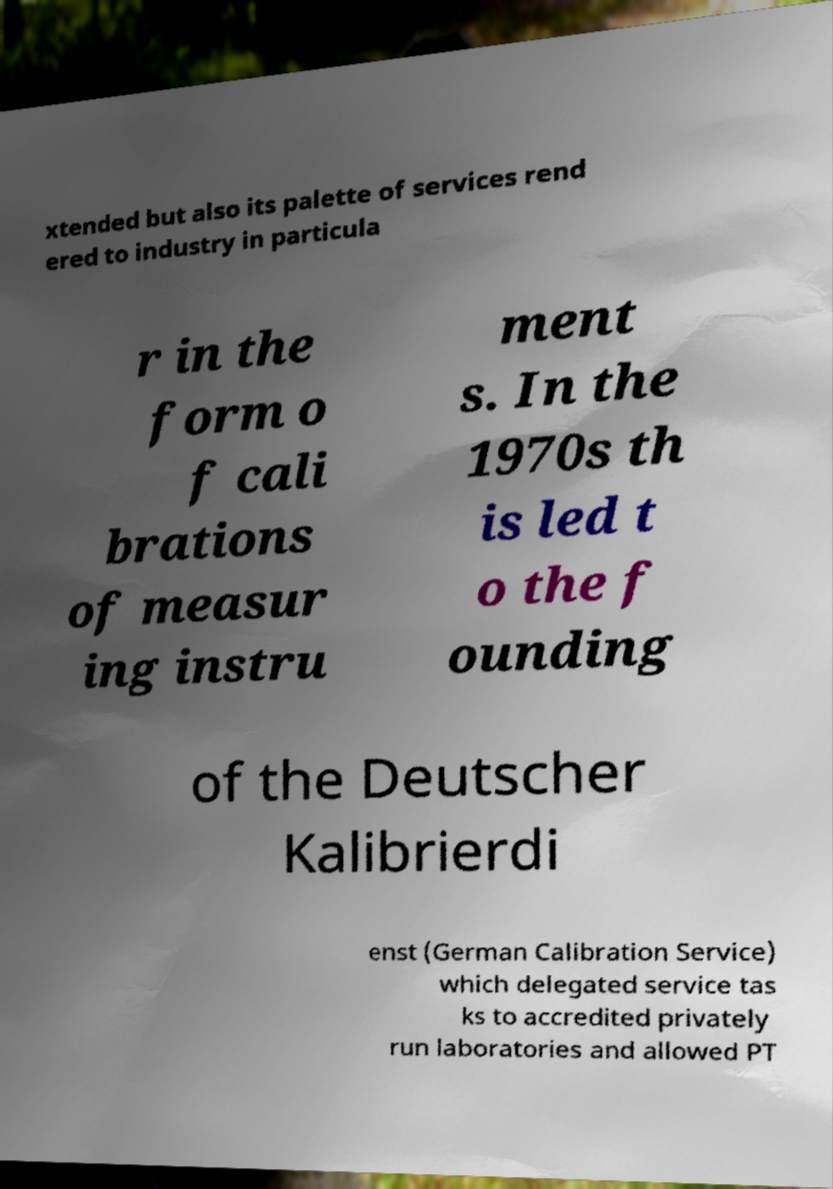Can you accurately transcribe the text from the provided image for me? xtended but also its palette of services rend ered to industry in particula r in the form o f cali brations of measur ing instru ment s. In the 1970s th is led t o the f ounding of the Deutscher Kalibrierdi enst (German Calibration Service) which delegated service tas ks to accredited privately run laboratories and allowed PT 